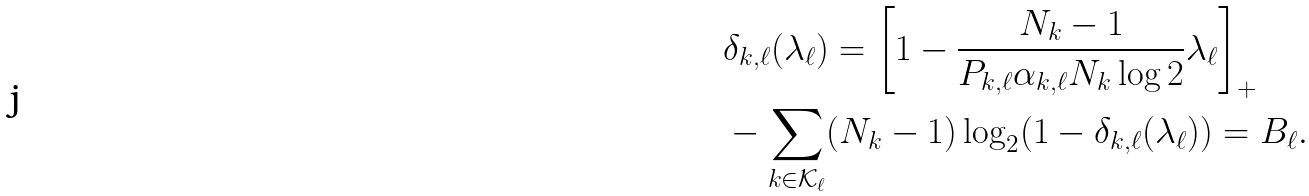Convert formula to latex. <formula><loc_0><loc_0><loc_500><loc_500>& \delta _ { k , \ell } ( { \lambda _ { \ell } } ) = \left [ 1 - \frac { N _ { k } - 1 } { P _ { k , \ell } \alpha _ { k , \ell } N _ { k } \log 2 } \lambda _ { \ell } \right ] _ { + } \\ & - \sum _ { k \in \mathcal { K } _ { \ell } } ( N _ { k } - 1 ) \log _ { 2 } ( 1 - \delta _ { k , \ell } ( \lambda _ { \ell } ) ) = B _ { \ell } .</formula> 